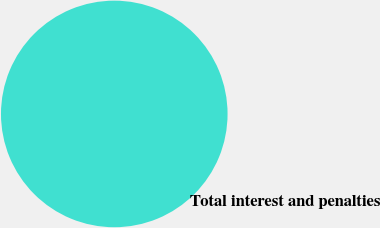Convert chart. <chart><loc_0><loc_0><loc_500><loc_500><pie_chart><fcel>Total interest and penalties<nl><fcel>100.0%<nl></chart> 